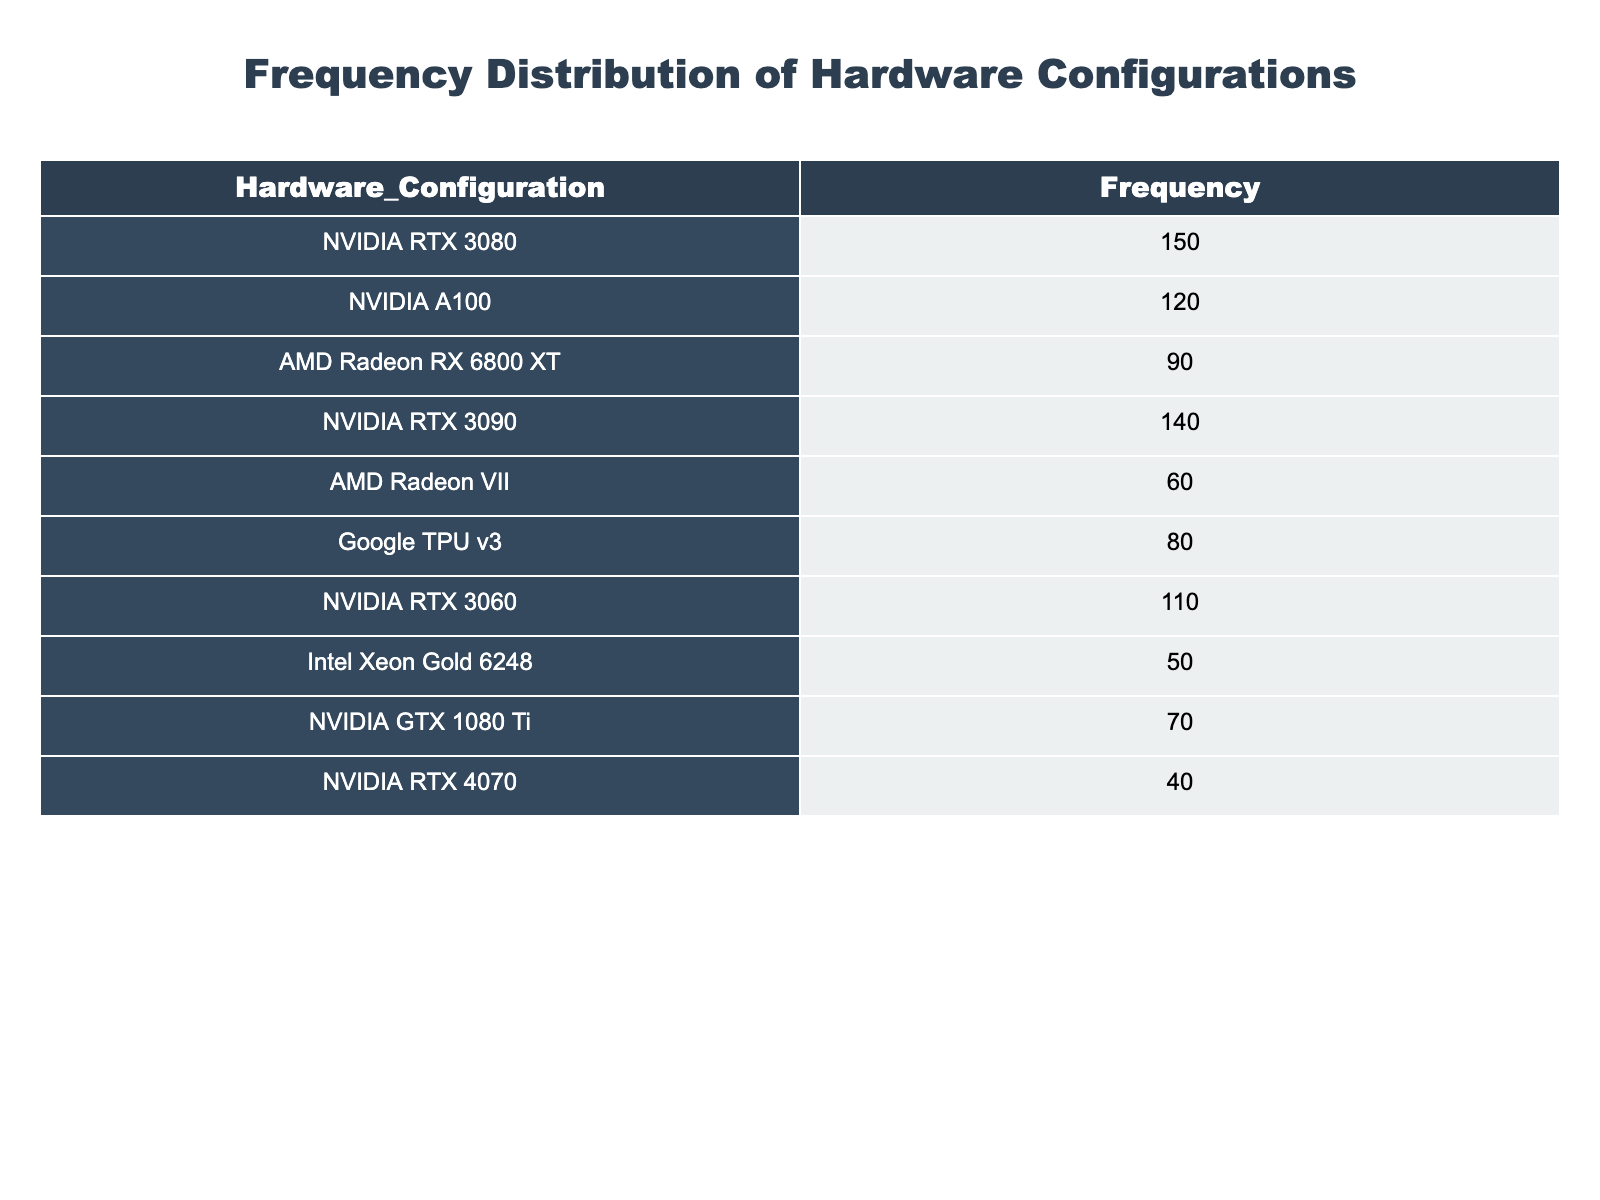What is the frequency of the NVIDIA A100? The frequency of the NVIDIA A100 is provided directly in the table under the Frequency column. It indicates how many instances of this hardware configuration are noted.
Answer: 120 What is the most popular hardware configuration based on frequency? To find the most popular configuration, we can look for the highest frequency value in the table. The NVIDIA RTX 3080 has the highest frequency of 150, making it the most popular.
Answer: NVIDIA RTX 3080 How many hardware configurations have a frequency greater than 100? The table lists frequencies, and we need to count how many configurations exceed 100. The following have frequencies greater than 100: NVIDIA RTX 3080 (150), NVIDIA RTX 3090 (140), NVIDIA RTX 3060 (110), and NVIDIA A100 (120). There are four such configurations.
Answer: 4 What is the total frequency of all hardware configurations listed? To find the total frequency, we sum all frequency values in the table: 150 + 120 + 90 + 140 + 60 + 80 + 110 + 50 + 70 + 40 = 1,010. Thus, the total frequency is 1,010.
Answer: 1010 Is there any configuration with a frequency of exactly 60? We look through the Frequency column to see if there is an entry with the value 60. The AMD Radeon VII has a frequency of 60, confirming that such a configuration exists.
Answer: Yes 